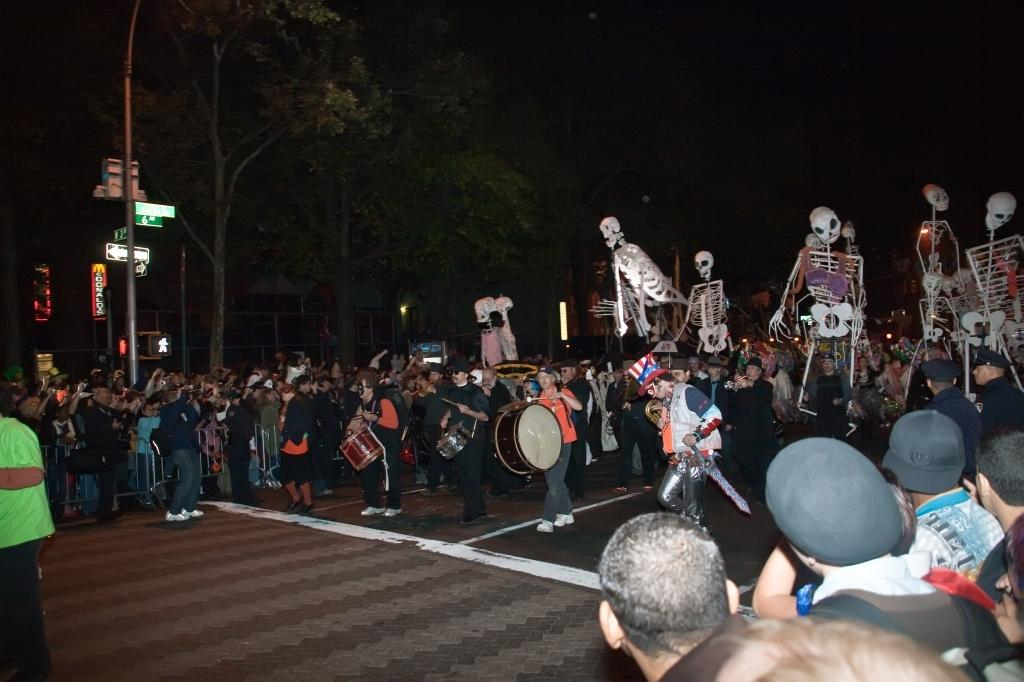What are the people in the image doing? The persons in the image are standing on the road and holding musical instruments. What can be seen in the background of the image? There are trees, buildings, and the sky visible in the background of the image. What type of prison can be seen in the image? There is no prison present in the image. What material is the iron structure made of in the image? There is no iron structure present in the image. 